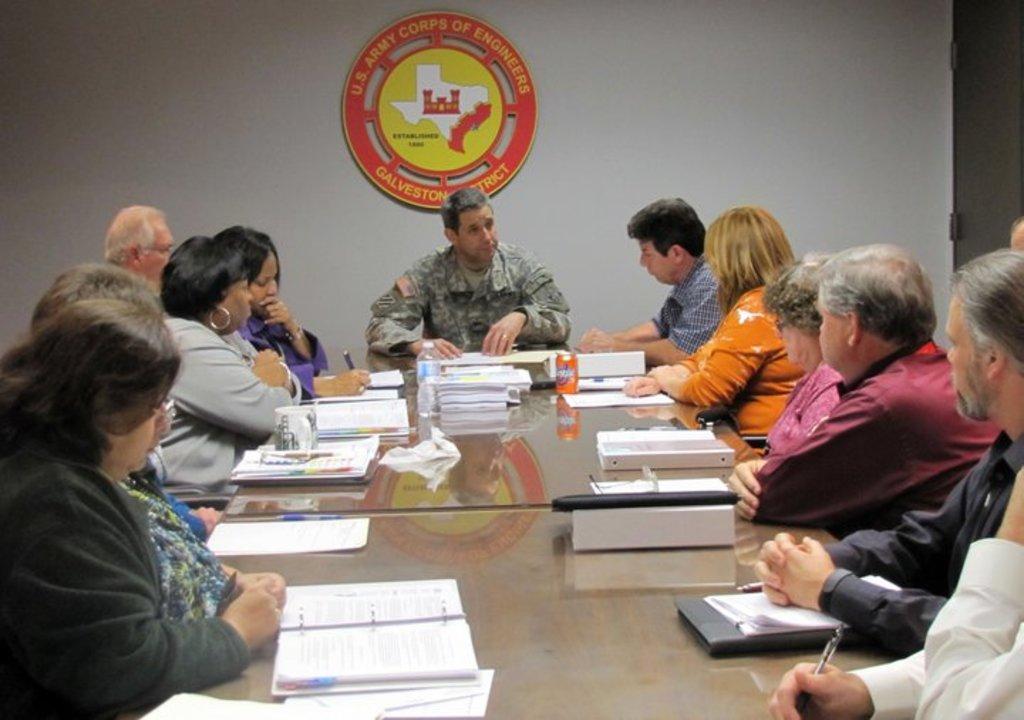Can you describe this image briefly? In this image, there are some persons wearing clothes and sitting in front of the table. This table contains some files. There is a logo at the top of the image. 